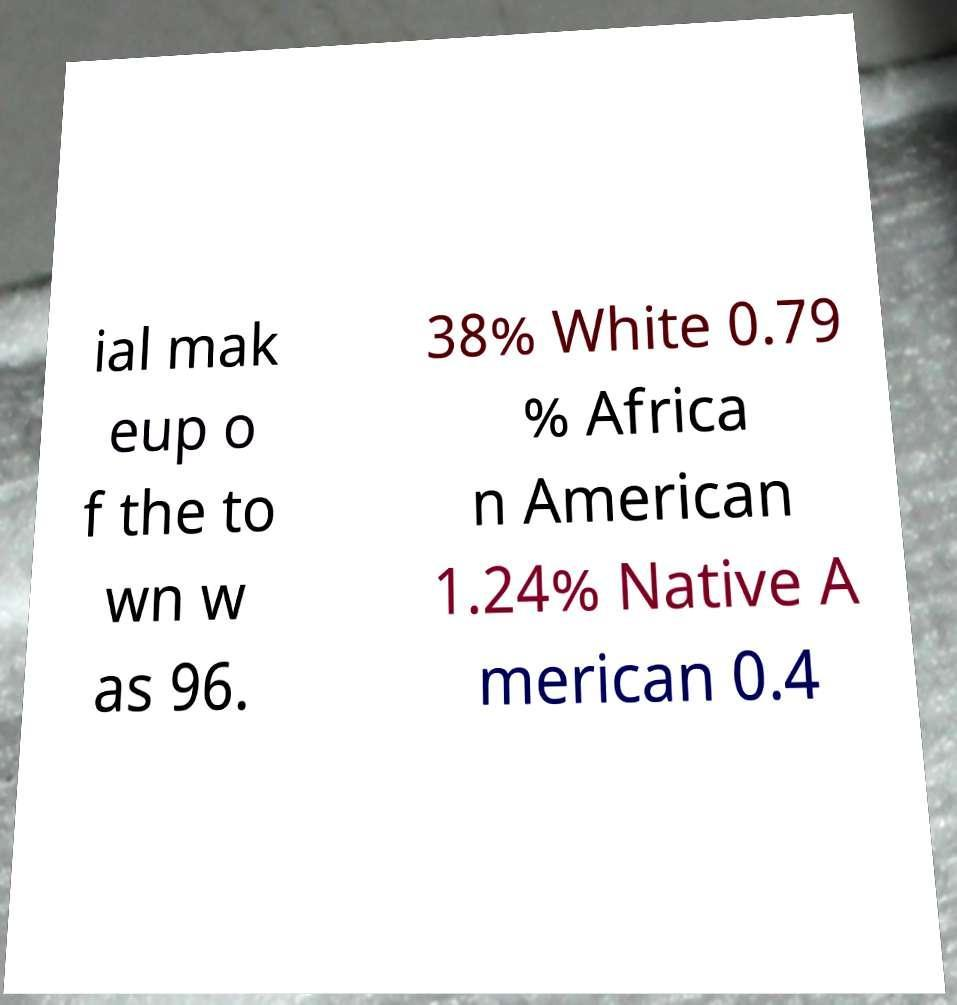Please read and relay the text visible in this image. What does it say? ial mak eup o f the to wn w as 96. 38% White 0.79 % Africa n American 1.24% Native A merican 0.4 